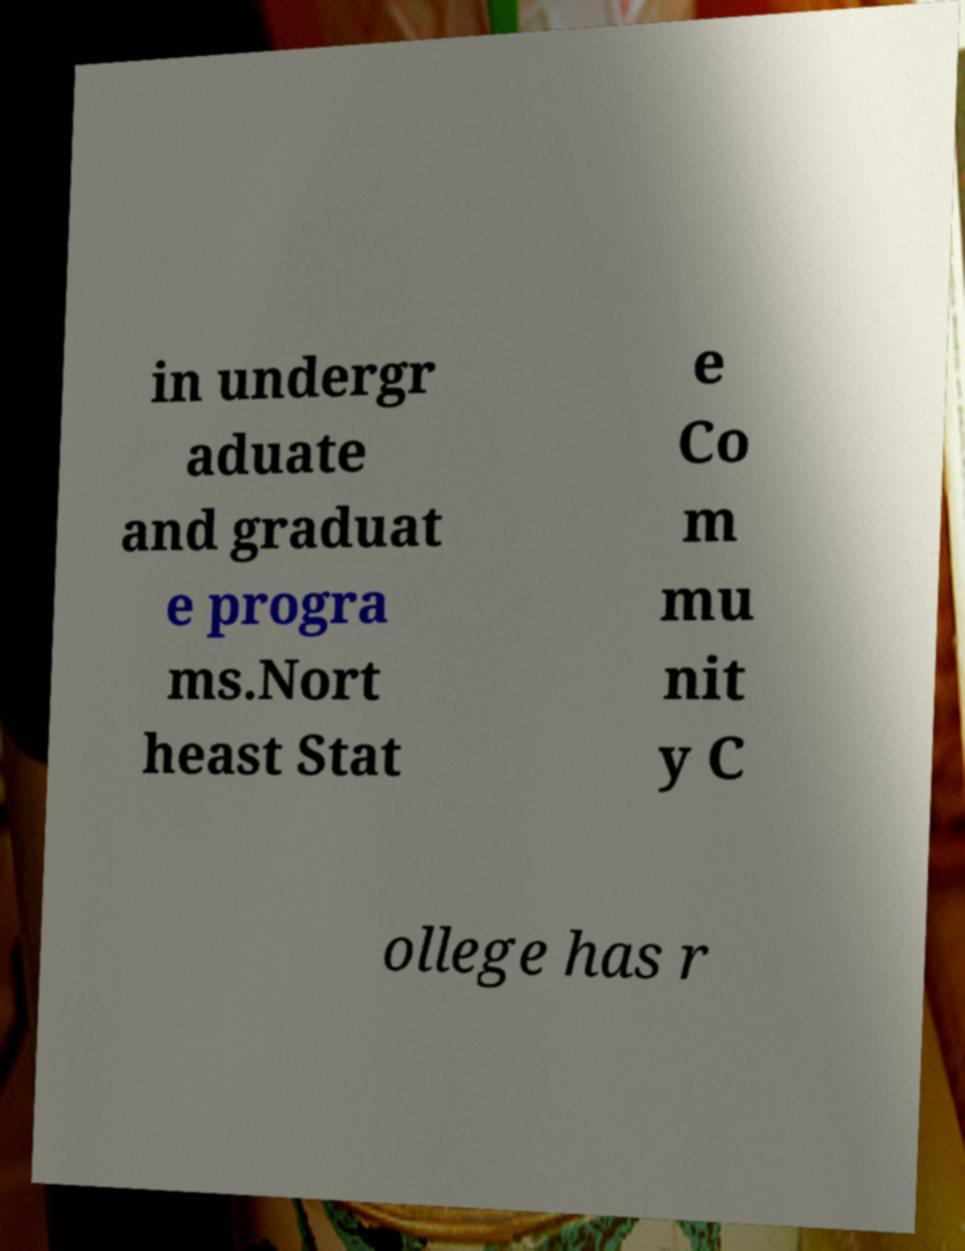There's text embedded in this image that I need extracted. Can you transcribe it verbatim? in undergr aduate and graduat e progra ms.Nort heast Stat e Co m mu nit y C ollege has r 